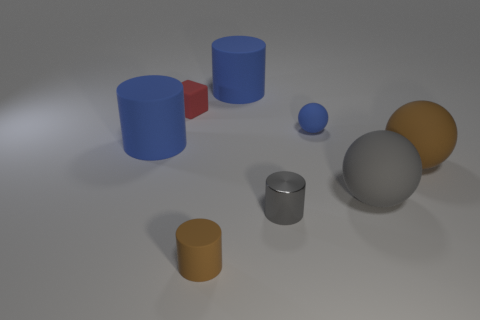Add 1 gray shiny cylinders. How many objects exist? 9 Subtract all big spheres. How many spheres are left? 1 Subtract 3 cylinders. How many cylinders are left? 1 Subtract all blue balls. How many balls are left? 2 Subtract all spheres. How many objects are left? 5 Add 6 big brown spheres. How many big brown spheres are left? 7 Add 3 brown matte spheres. How many brown matte spheres exist? 4 Subtract 0 purple balls. How many objects are left? 8 Subtract all cyan cubes. Subtract all green cylinders. How many cubes are left? 1 Subtract all cyan cylinders. How many red spheres are left? 0 